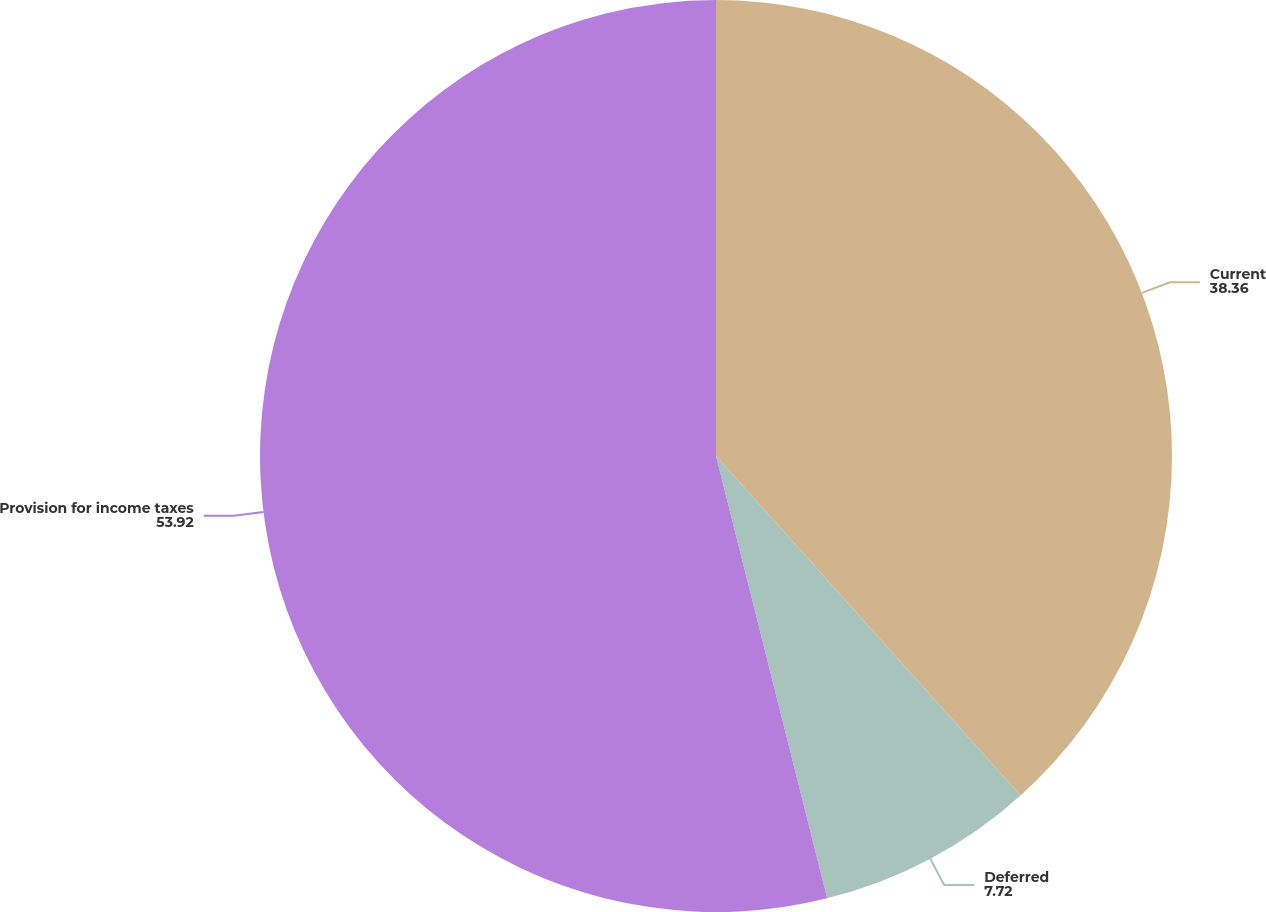<chart> <loc_0><loc_0><loc_500><loc_500><pie_chart><fcel>Current<fcel>Deferred<fcel>Provision for income taxes<nl><fcel>38.36%<fcel>7.72%<fcel>53.92%<nl></chart> 